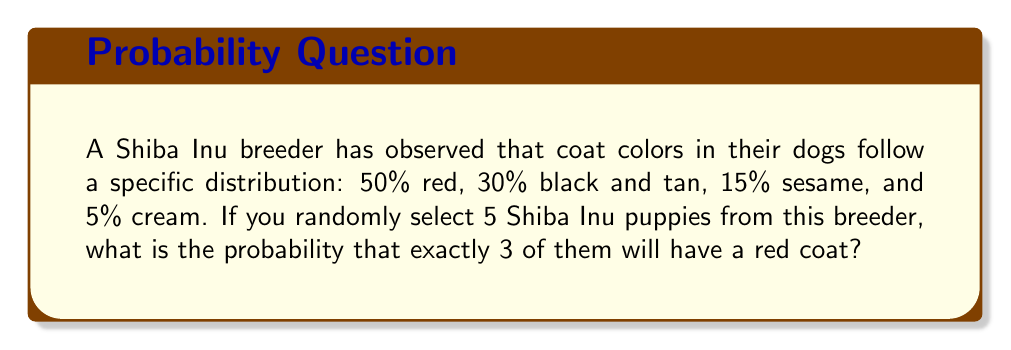Give your solution to this math problem. To solve this problem, we can use the binomial probability distribution. The binomial distribution is used when we have a fixed number of independent trials (selecting 5 puppies) with two possible outcomes for each trial (red coat or not red coat).

Let's define our variables:
$n = 5$ (number of puppies selected)
$k = 3$ (number of red coat puppies we want)
$p = 0.5$ (probability of a red coat)

The binomial probability formula is:

$$P(X = k) = \binom{n}{k} p^k (1-p)^{n-k}$$

Where $\binom{n}{k}$ is the binomial coefficient, calculated as:

$$\binom{n}{k} = \frac{n!}{k!(n-k)!}$$

Step 1: Calculate the binomial coefficient
$$\binom{5}{3} = \frac{5!}{3!(5-3)!} = \frac{5 \cdot 4}{2 \cdot 1} = 10$$

Step 2: Apply the binomial probability formula
$$P(X = 3) = 10 \cdot (0.5)^3 \cdot (1-0.5)^{5-3}$$
$$= 10 \cdot (0.5)^3 \cdot (0.5)^2$$
$$= 10 \cdot 0.125 \cdot 0.25$$
$$= 0.3125$$

Therefore, the probability of selecting exactly 3 red coat Shiba Inu puppies out of 5 randomly selected puppies is 0.3125 or 31.25%.
Answer: 0.3125 